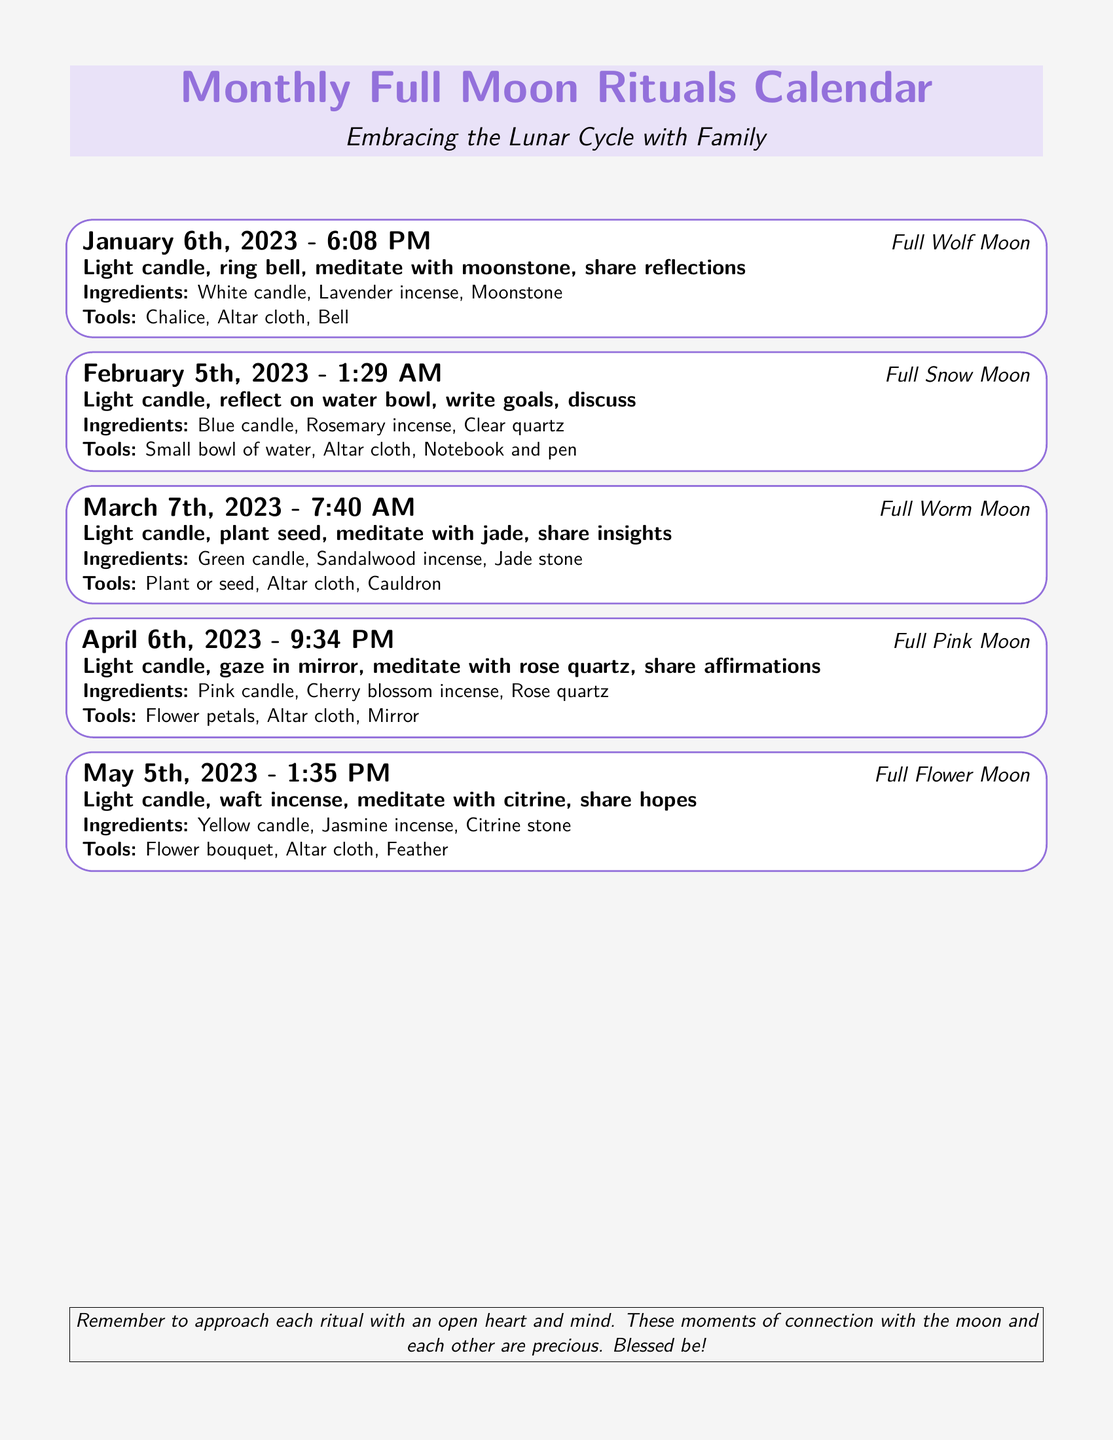What date is the Full Wolf Moon? The date of the Full Wolf Moon is provided in the document as January 6th, 2023.
Answer: January 6th, 2023 What time does the Full Flower Moon occur? The document specifies the time for the Full Flower Moon as 1:35 PM on May 5th, 2023.
Answer: 1:35 PM What is the main activity for the Full Snow Moon? The document lists the main activities for the Full Snow Moon, including reflecting on a water bowl and writing goals.
Answer: Reflect on water bowl, write goals Which candle color is used for the Full Pink Moon? The color of the candle for the Full Pink Moon is stated as pink in the document.
Answer: Pink How many rituals are listed in the document? The document details a total of five full moon rituals that are celebrated throughout the months specified.
Answer: Five What special ingredient is needed for the Full Worm Moon? The document mentions the jade stone as the special ingredient for the Full Worm Moon ritual.
Answer: Jade stone What ritual activity is common among most full moon events? The document indicates that lighting a candle is a common activity throughout the listed rituals for each full moon.
Answer: Light candle What is the significance of these rituals according to the document? The document emphasizes that these rituals connect the participants with the moon and each other, marking them as precious moments.
Answer: Connection with the moon and each other 